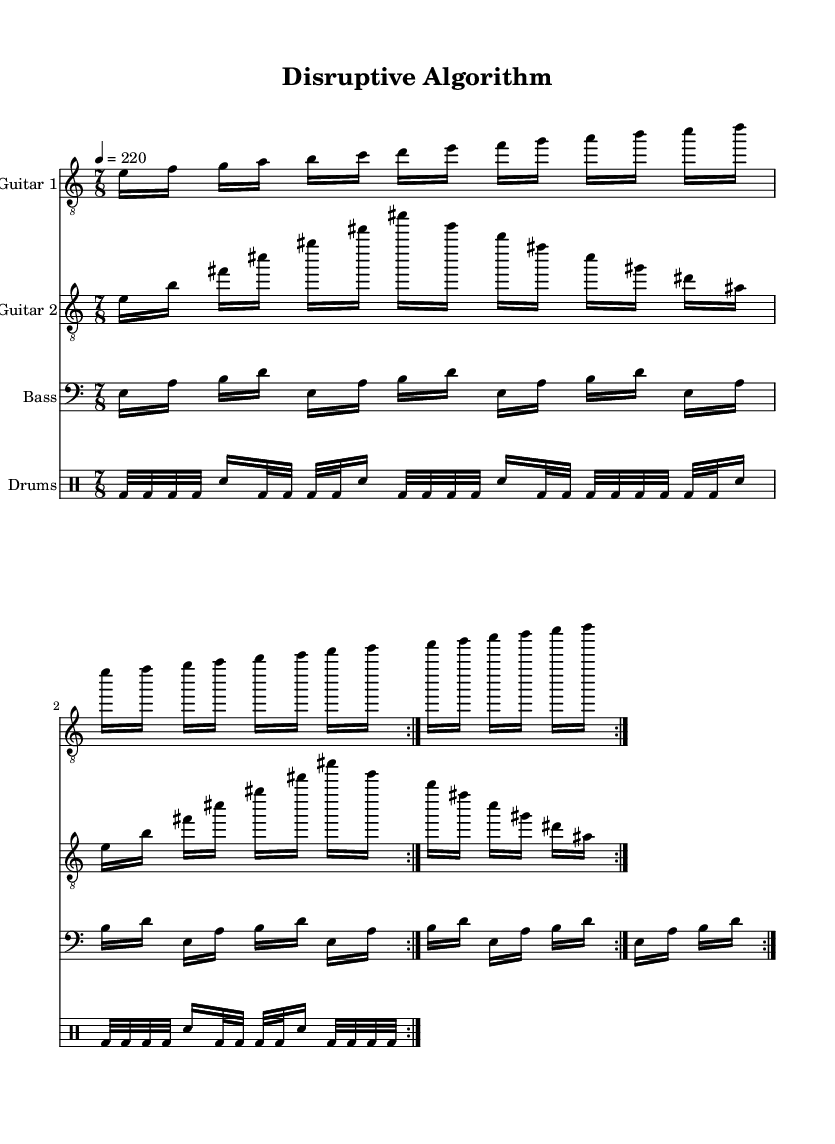What is the key signature of this music? The key signature is E phrygian, which consists of 1 sharp (F#). This can be determined by observing the key indicated in the global section of the LilyPond code.
Answer: E phrygian What is the time signature of this music? The time signature is 7/8, as indicated in the global section of the LilyPond code. This means there are 7 eighth notes in each measure.
Answer: 7/8 What is the tempo of this piece? The tempo is set to 220 beats per minute, as specified in the global section with the command "4 = 220". This indicates the speed at which the piece should be played.
Answer: 220 How many repeats are indicated in the music? There are 2 repeats specified for the guitar and bass parts, as mentioned by the "volta 2" directive in the code, which means each section will be played twice.
Answer: 2 Which instrument plays the bass line? The instrument is labeled as "Bass" in the score, and the part for the bass is written in the bass clef, distinguishing it from the guitar parts.
Answer: Bass What type of meter is primarily used in this piece? This piece primarily uses an irregular meter with 7/8 time, which often features a strong sense of syncopation and rhythmic complexity typical of technical death metal.
Answer: Irregular meter How many staves are included in the score? The score includes four staves: one for Guitar 1, one for Guitar 2, one for Bass, and one for Drums, as indicated in the score section of the LilyPond code.
Answer: Four 